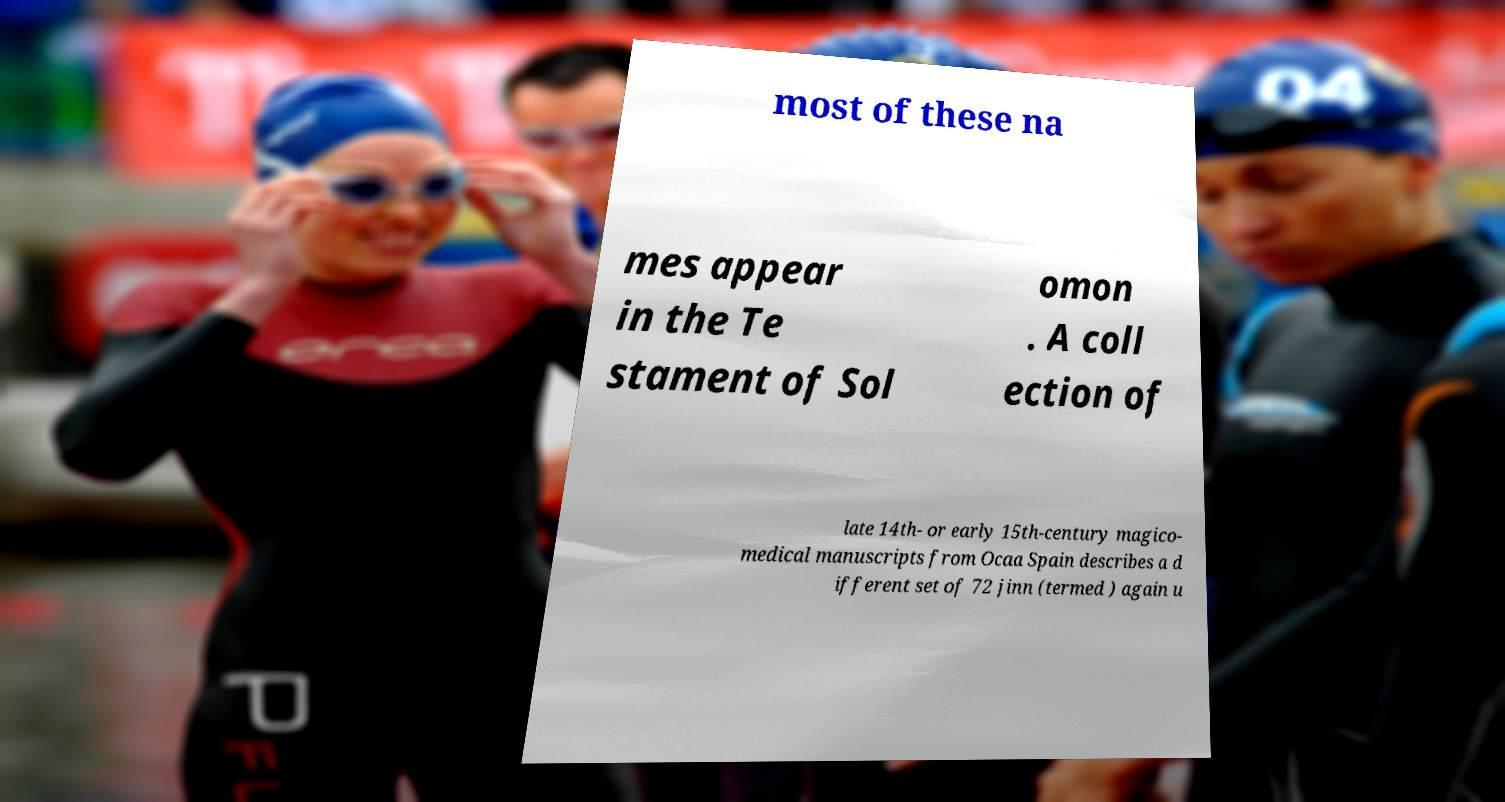Can you read and provide the text displayed in the image?This photo seems to have some interesting text. Can you extract and type it out for me? most of these na mes appear in the Te stament of Sol omon . A coll ection of late 14th- or early 15th-century magico- medical manuscripts from Ocaa Spain describes a d ifferent set of 72 jinn (termed ) again u 